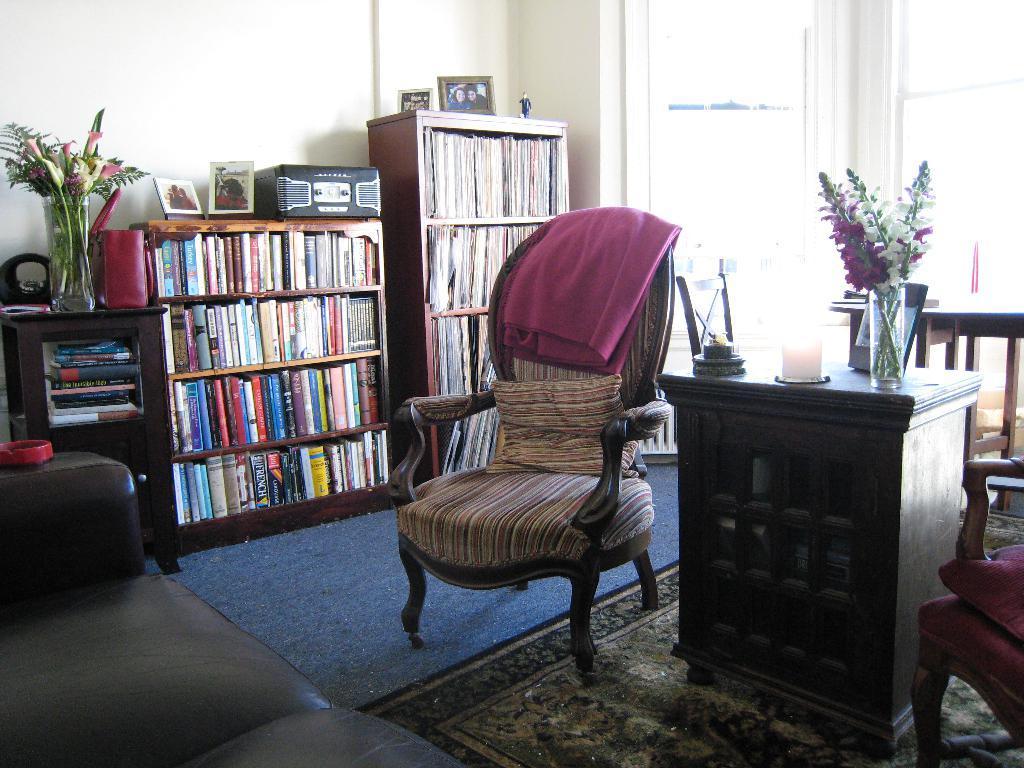In one or two sentences, can you explain what this image depicts? In this picture we can see a room with chair pillows, bed sheet on it and aside to that candle, vase with flowers in it on table and here we can see books in racks, photo frames, sofa, wall, window. 